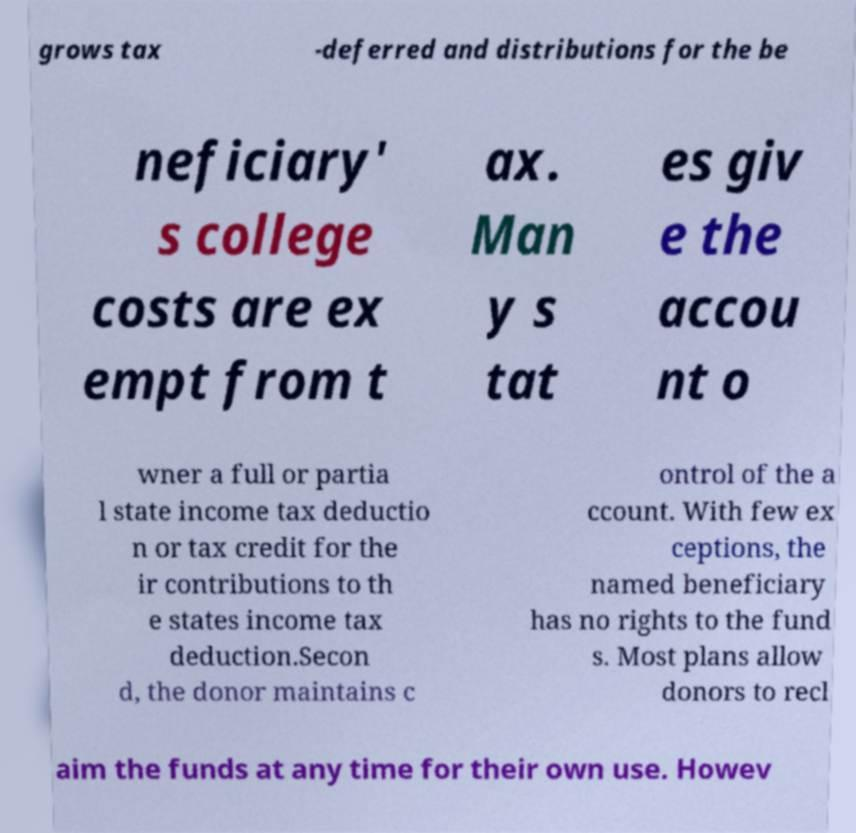What messages or text are displayed in this image? I need them in a readable, typed format. grows tax -deferred and distributions for the be neficiary' s college costs are ex empt from t ax. Man y s tat es giv e the accou nt o wner a full or partia l state income tax deductio n or tax credit for the ir contributions to th e states income tax deduction.Secon d, the donor maintains c ontrol of the a ccount. With few ex ceptions, the named beneficiary has no rights to the fund s. Most plans allow donors to recl aim the funds at any time for their own use. Howev 